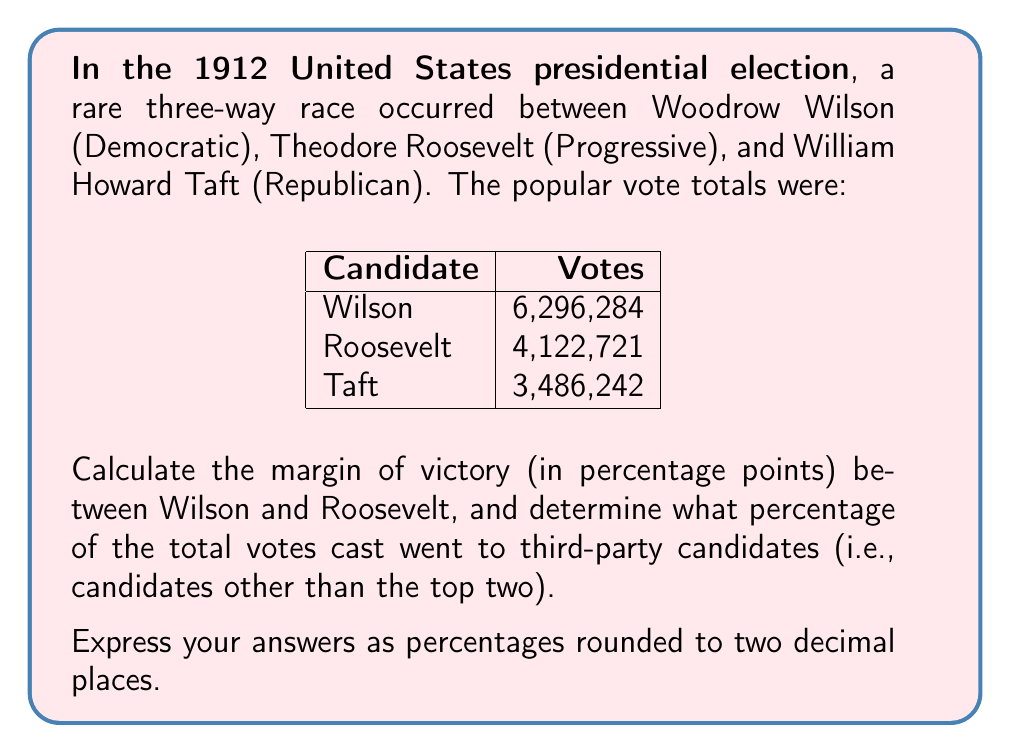Give your solution to this math problem. Let's approach this step-by-step:

1. Calculate the total number of votes cast:
   $$ \text{Total votes} = 6,296,284 + 4,122,721 + 3,486,242 = 13,905,247 $$

2. Calculate the percentage of votes for Wilson:
   $$ \text{Wilson's percentage} = \frac{6,296,284}{13,905,247} \times 100 = 45.28\% $$

3. Calculate the percentage of votes for Roosevelt:
   $$ \text{Roosevelt's percentage} = \frac{4,122,721}{13,905,247} \times 100 = 29.65\% $$

4. Calculate the margin of victory:
   $$ \text{Margin} = 45.28\% - 29.65\% = 15.63\% $$

5. To calculate the percentage of votes for third-party candidates, we need to consider Taft's votes as the third-party votes in this case:
   $$ \text{Third-party percentage} = \frac{3,486,242}{13,905,247} \times 100 = 25.07\% $$

Thus, the margin of victory between Wilson and Roosevelt was 15.63 percentage points, and 25.07% of the total votes went to third-party candidates (in this case, Taft).
Answer: 15.63%, 25.07% 